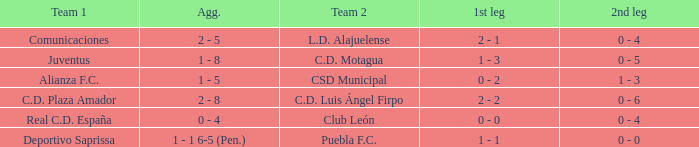What is the initial leg where team 1 is c.d. plaza amador? 2 - 2. 